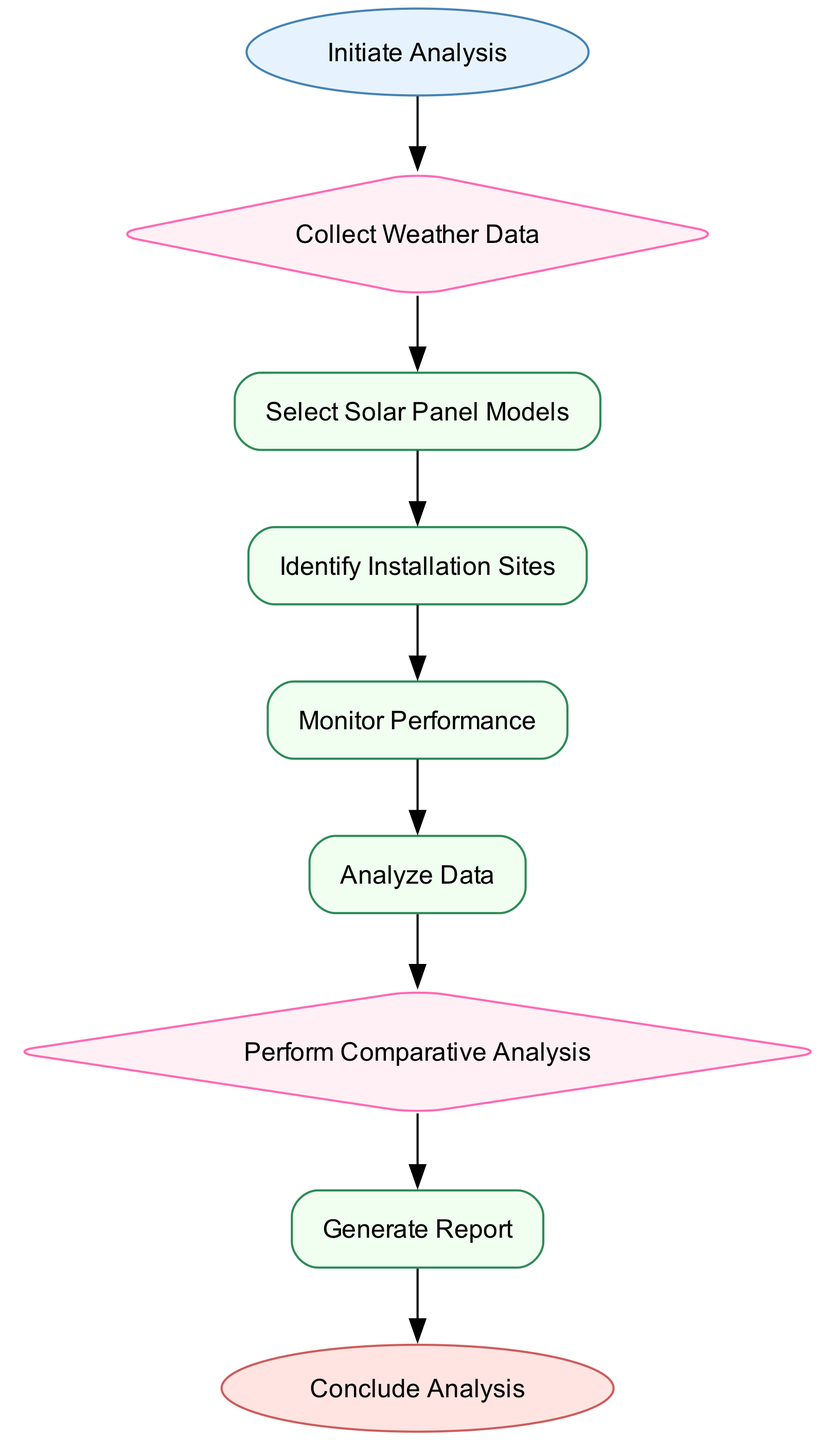What is the starting point of the analysis? The starting point is explicitly mentioned in the diagram as "Initiate Analysis." Therefore, the answer is simply the term itself as it represents the first step in the pathway.
Answer: Initiate Analysis How many process elements are present in the diagram? The diagram includes four process elements: "Select Solar Panel Models," "Identify Installation Sites," "Monitor Performance," and "Analyze Data." By counting these distinct processes, we arrive at the number.
Answer: Four What follows after "Collect Weather Data"? In the diagram, the flow from "Collect Weather Data" leads directly to the next process which is "Select Solar Panel Models." This indicates the order of operations and the sequential nature of the analysis.
Answer: Select Solar Panel Models Which models of solar panels are to be selected? The models specified in the diagram for selection include monocrystalline, polycrystalline, and thin-film technologies. These are listed directly within the description of the "Select Solar Panel Models" process.
Answer: Monocrystalline, Polycrystalline, Thin-film What is the outcome following the "Perform Comparative Analysis"? After the "Perform Comparative Analysis," the next step as shown in the diagram is "Generate Report." This illustrates the process sequence and the progression of analysis towards final reporting.
Answer: Generate Report Which tool is suggested for data analysis? The diagram mentions the use of statistical software such as RStudio and Python for data analysis. By identifying these specific tools, we can determine the recommended resources for analyzing performance data.
Answer: RStudio, Python How many decision nodes are present in the diagram? There are two decision nodes in the diagram: "Collect Weather Data" and "Perform Comparative Analysis." By identifying and counting these nodes, we establish the total number of decision points.
Answer: Two What is the final outcome of the clinical pathway? The clinical pathway concludes with "Conclude Analysis," which indicates the end of the analysis process and the delivery of recommendations for stakeholders regarding solar panel models and installation sites.
Answer: Conclude Analysis 